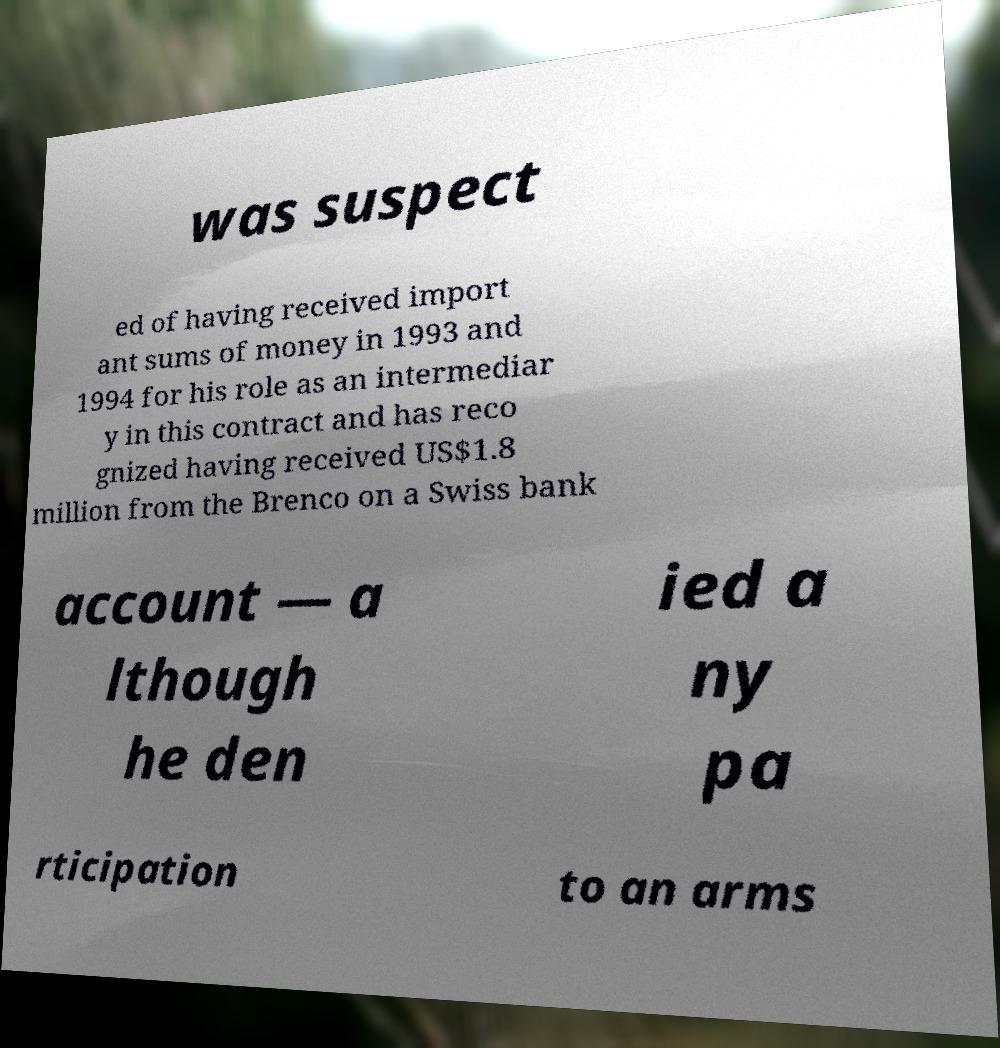I need the written content from this picture converted into text. Can you do that? was suspect ed of having received import ant sums of money in 1993 and 1994 for his role as an intermediar y in this contract and has reco gnized having received US$1.8 million from the Brenco on a Swiss bank account — a lthough he den ied a ny pa rticipation to an arms 